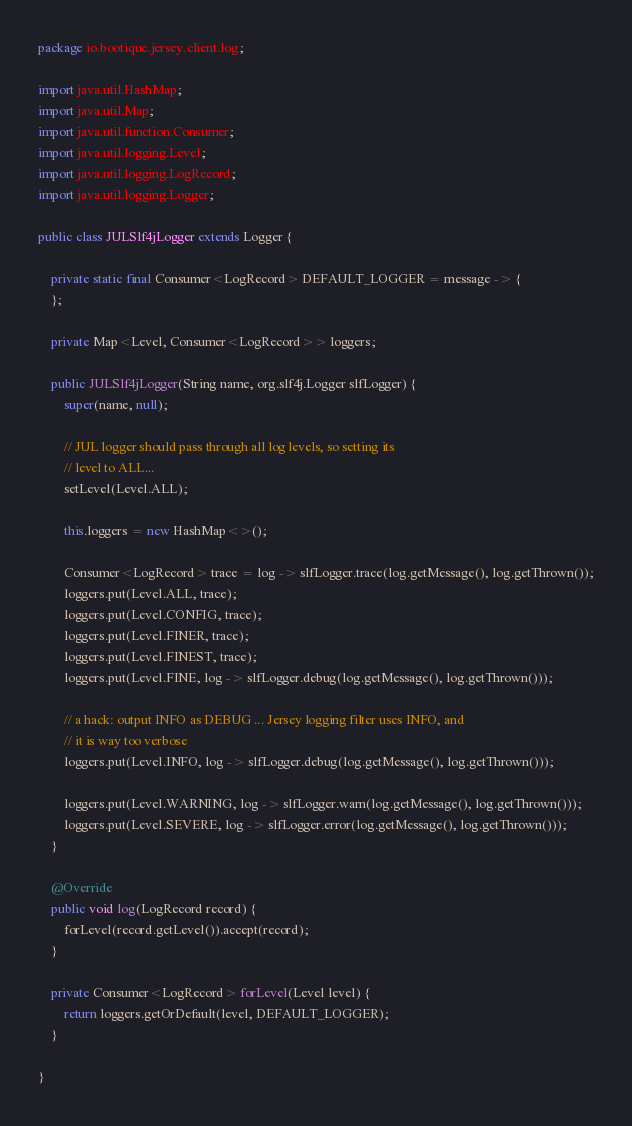<code> <loc_0><loc_0><loc_500><loc_500><_Java_>package io.bootique.jersey.client.log;

import java.util.HashMap;
import java.util.Map;
import java.util.function.Consumer;
import java.util.logging.Level;
import java.util.logging.LogRecord;
import java.util.logging.Logger;

public class JULSlf4jLogger extends Logger {

	private static final Consumer<LogRecord> DEFAULT_LOGGER = message -> {
	};

	private Map<Level, Consumer<LogRecord>> loggers;

	public JULSlf4jLogger(String name, org.slf4j.Logger slfLogger) {
		super(name, null);

		// JUL logger should pass through all log levels, so setting its
		// level to ALL...
		setLevel(Level.ALL);

		this.loggers = new HashMap<>();

		Consumer<LogRecord> trace = log -> slfLogger.trace(log.getMessage(), log.getThrown());
		loggers.put(Level.ALL, trace);
		loggers.put(Level.CONFIG, trace);
		loggers.put(Level.FINER, trace);
		loggers.put(Level.FINEST, trace);
		loggers.put(Level.FINE, log -> slfLogger.debug(log.getMessage(), log.getThrown()));

		// a hack: output INFO as DEBUG ... Jersey logging filter uses INFO, and
		// it is way too verbose
		loggers.put(Level.INFO, log -> slfLogger.debug(log.getMessage(), log.getThrown()));

		loggers.put(Level.WARNING, log -> slfLogger.warn(log.getMessage(), log.getThrown()));
		loggers.put(Level.SEVERE, log -> slfLogger.error(log.getMessage(), log.getThrown()));
	}

	@Override
	public void log(LogRecord record) {
		forLevel(record.getLevel()).accept(record);
	}

	private Consumer<LogRecord> forLevel(Level level) {
		return loggers.getOrDefault(level, DEFAULT_LOGGER);
	}

}
</code> 